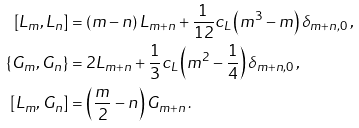Convert formula to latex. <formula><loc_0><loc_0><loc_500><loc_500>\left [ L _ { m } , L _ { n } \right ] & = \left ( m - n \right ) L _ { m + n } + \frac { 1 } { 1 2 } c _ { L } \left ( m ^ { 3 } - m \right ) \delta _ { m + n , 0 } \, , \\ \left \{ G _ { m } , G _ { n } \right \} & = 2 L _ { m + n } + \frac { 1 } { 3 } c _ { L } \left ( m ^ { 2 } - \frac { 1 } { 4 } \right ) \delta _ { m + n , 0 } \, , \\ \left [ L _ { m } , G _ { n } \right ] & = \left ( \frac { m } { 2 } - n \right ) G _ { m + n } \, .</formula> 